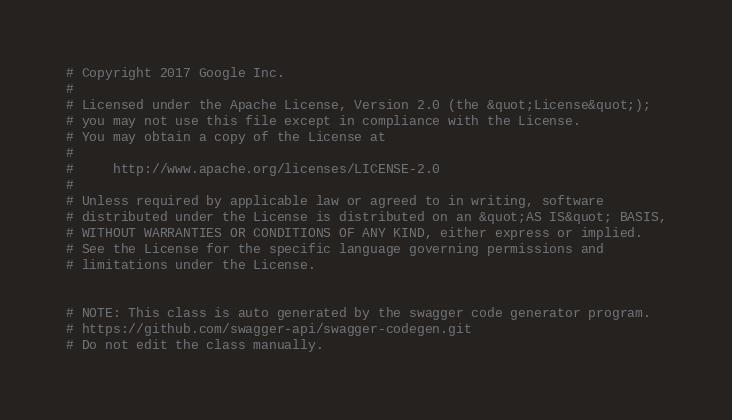Convert code to text. <code><loc_0><loc_0><loc_500><loc_500><_Elixir_># Copyright 2017 Google Inc.
#
# Licensed under the Apache License, Version 2.0 (the &quot;License&quot;);
# you may not use this file except in compliance with the License.
# You may obtain a copy of the License at
#
#     http://www.apache.org/licenses/LICENSE-2.0
#
# Unless required by applicable law or agreed to in writing, software
# distributed under the License is distributed on an &quot;AS IS&quot; BASIS,
# WITHOUT WARRANTIES OR CONDITIONS OF ANY KIND, either express or implied.
# See the License for the specific language governing permissions and
# limitations under the License.


# NOTE: This class is auto generated by the swagger code generator program.
# https://github.com/swagger-api/swagger-codegen.git
# Do not edit the class manually.
</code> 